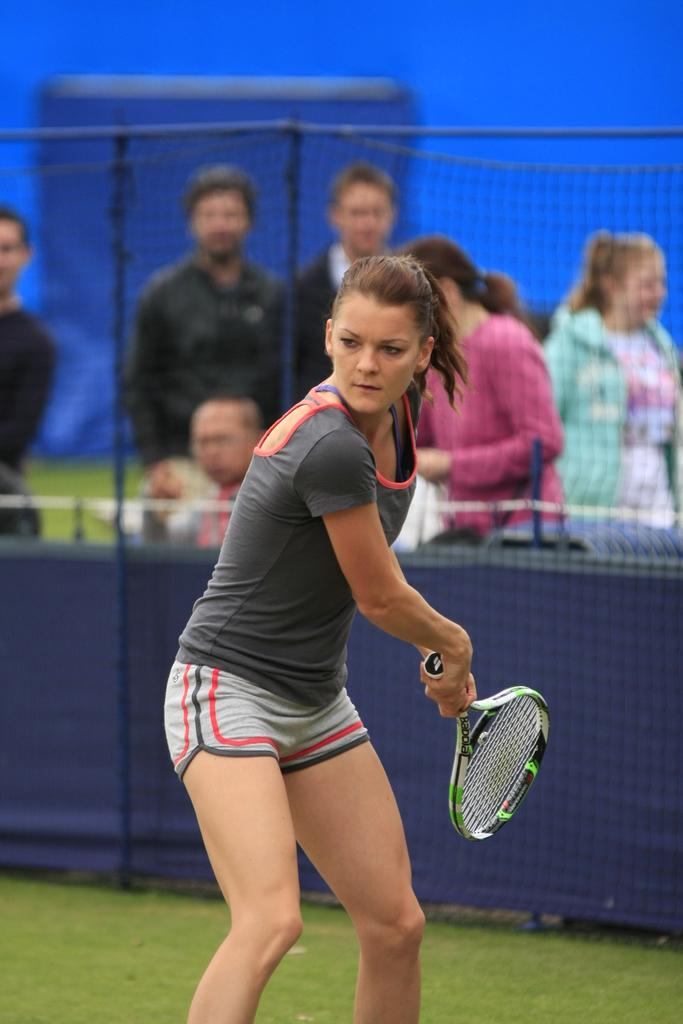Who is the main subject in the image? There is a woman in the image. What is the woman doing in the image? The woman is standing and holding a tennis racket in her hands. Can you describe the background of the image? There are people visible in the background and a fence in the background. What type of cannon is visible in the image? There is no cannon present in the image. Can you describe the clouds in the image? There are no clouds visible in the image. 